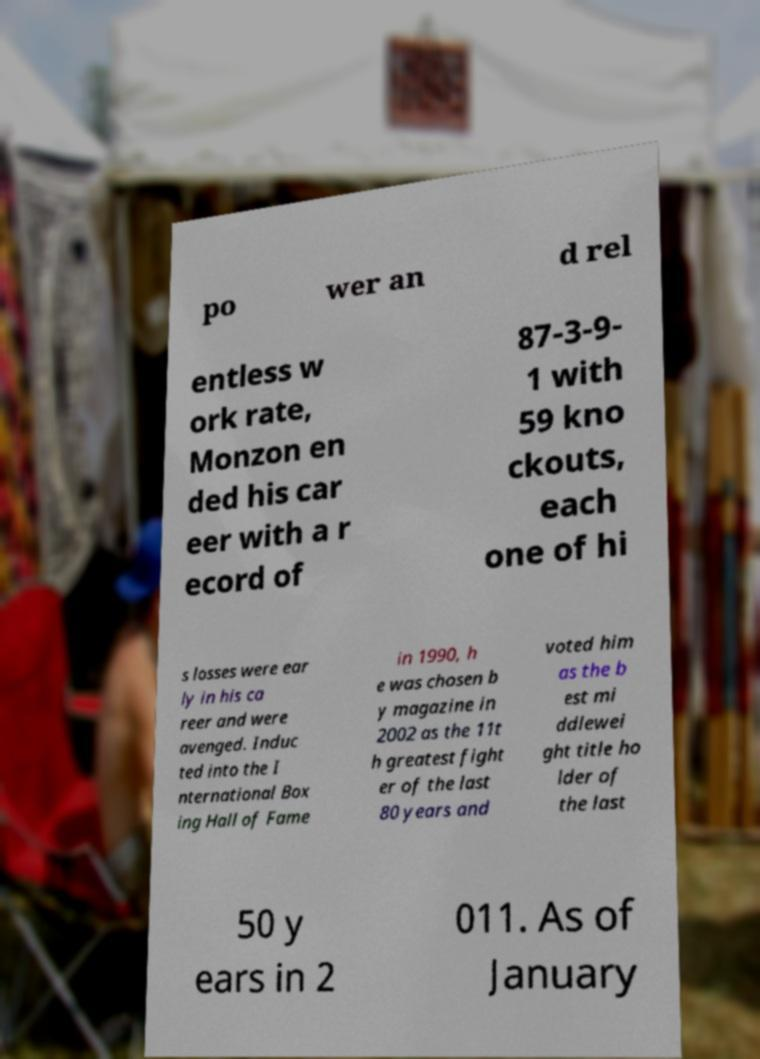For documentation purposes, I need the text within this image transcribed. Could you provide that? po wer an d rel entless w ork rate, Monzon en ded his car eer with a r ecord of 87-3-9- 1 with 59 kno ckouts, each one of hi s losses were ear ly in his ca reer and were avenged. Induc ted into the I nternational Box ing Hall of Fame in 1990, h e was chosen b y magazine in 2002 as the 11t h greatest fight er of the last 80 years and voted him as the b est mi ddlewei ght title ho lder of the last 50 y ears in 2 011. As of January 